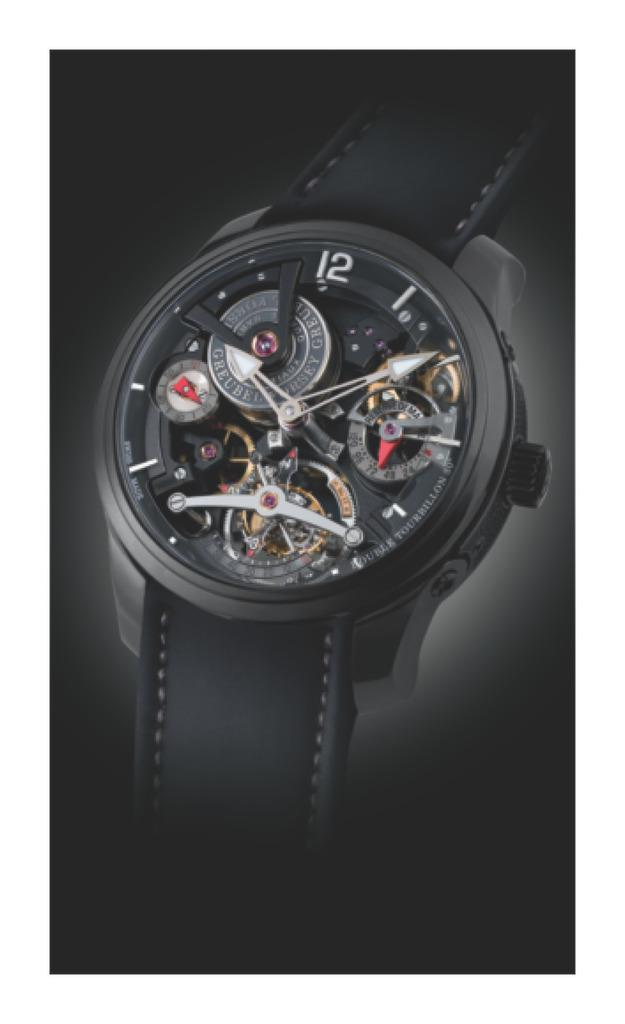What is the main subject of the image? The main subject of the image is a watch. Can you describe the color of the watch? The watch is black in color. What can be observed about the background of the image? The background of the image is dark. How does the butter affect the watch in the image? There is no butter present in the image, so it cannot affect the watch. 